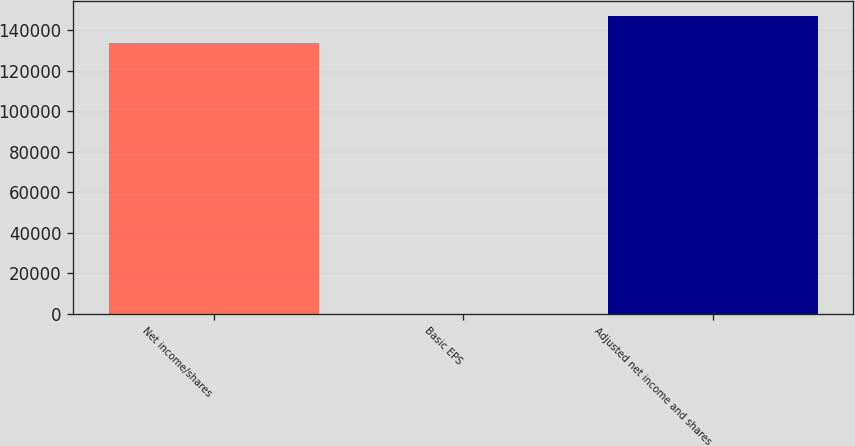Convert chart. <chart><loc_0><loc_0><loc_500><loc_500><bar_chart><fcel>Net income/shares<fcel>Basic EPS<fcel>Adjusted net income and shares<nl><fcel>133575<fcel>2.36<fcel>146932<nl></chart> 